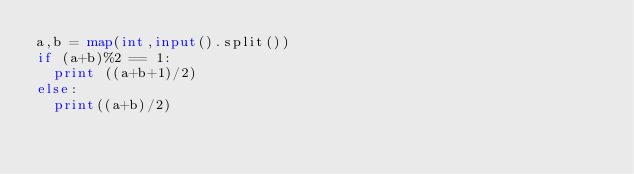Convert code to text. <code><loc_0><loc_0><loc_500><loc_500><_Python_>a,b = map(int,input().split())
if (a+b)%2 == 1:
  print ((a+b+1)/2)
else:
  print((a+b)/2)
</code> 